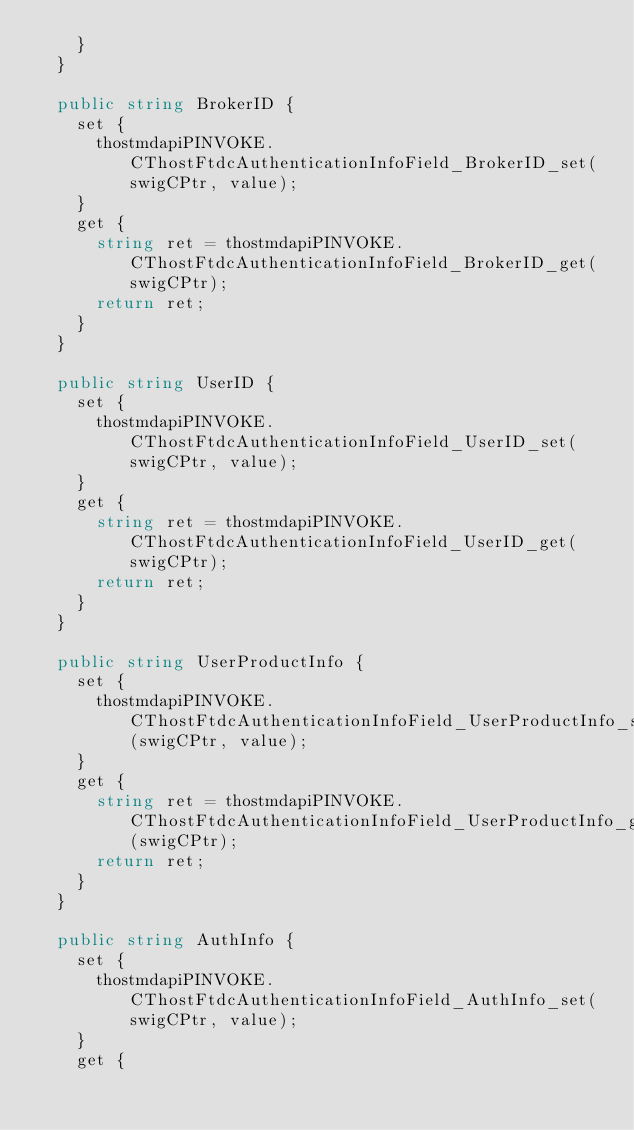Convert code to text. <code><loc_0><loc_0><loc_500><loc_500><_C#_>    }
  }

  public string BrokerID {
    set {
      thostmdapiPINVOKE.CThostFtdcAuthenticationInfoField_BrokerID_set(swigCPtr, value);
    } 
    get {
      string ret = thostmdapiPINVOKE.CThostFtdcAuthenticationInfoField_BrokerID_get(swigCPtr);
      return ret;
    } 
  }

  public string UserID {
    set {
      thostmdapiPINVOKE.CThostFtdcAuthenticationInfoField_UserID_set(swigCPtr, value);
    } 
    get {
      string ret = thostmdapiPINVOKE.CThostFtdcAuthenticationInfoField_UserID_get(swigCPtr);
      return ret;
    } 
  }

  public string UserProductInfo {
    set {
      thostmdapiPINVOKE.CThostFtdcAuthenticationInfoField_UserProductInfo_set(swigCPtr, value);
    } 
    get {
      string ret = thostmdapiPINVOKE.CThostFtdcAuthenticationInfoField_UserProductInfo_get(swigCPtr);
      return ret;
    } 
  }

  public string AuthInfo {
    set {
      thostmdapiPINVOKE.CThostFtdcAuthenticationInfoField_AuthInfo_set(swigCPtr, value);
    } 
    get {</code> 